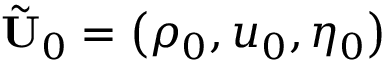Convert formula to latex. <formula><loc_0><loc_0><loc_500><loc_500>\tilde { U } _ { 0 } = \left ( { \rho _ { 0 } , u _ { 0 } , \eta _ { 0 } } \right )</formula> 